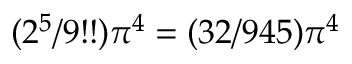<formula> <loc_0><loc_0><loc_500><loc_500>( 2 ^ { 5 } / 9 ! ! ) \pi ^ { 4 } = ( 3 2 / 9 4 5 ) \pi ^ { 4 }</formula> 